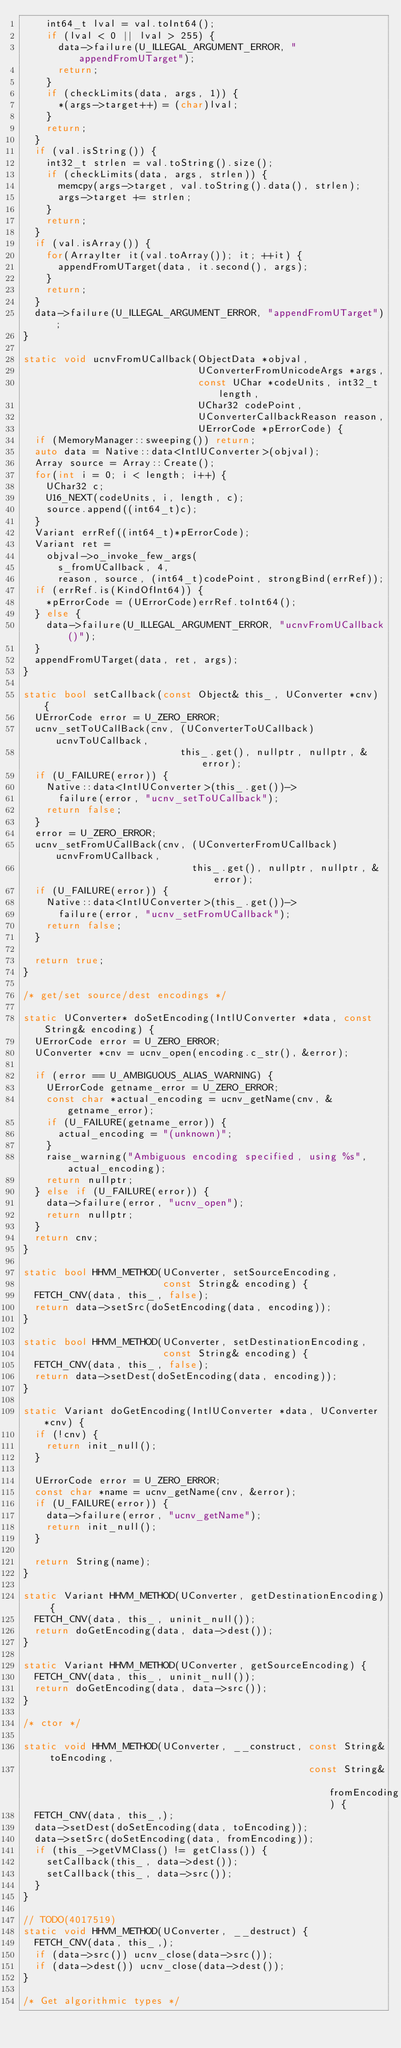<code> <loc_0><loc_0><loc_500><loc_500><_C++_>    int64_t lval = val.toInt64();
    if (lval < 0 || lval > 255) {
      data->failure(U_ILLEGAL_ARGUMENT_ERROR, "appendFromUTarget");
      return;
    }
    if (checkLimits(data, args, 1)) {
      *(args->target++) = (char)lval;
    }
    return;
  }
  if (val.isString()) {
    int32_t strlen = val.toString().size();
    if (checkLimits(data, args, strlen)) {
      memcpy(args->target, val.toString().data(), strlen);
      args->target += strlen;
    }
    return;
  }
  if (val.isArray()) {
    for(ArrayIter it(val.toArray()); it; ++it) {
      appendFromUTarget(data, it.second(), args);
    }
    return;
  }
  data->failure(U_ILLEGAL_ARGUMENT_ERROR, "appendFromUTarget");
}

static void ucnvFromUCallback(ObjectData *objval,
                              UConverterFromUnicodeArgs *args,
                              const UChar *codeUnits, int32_t length,
                              UChar32 codePoint,
                              UConverterCallbackReason reason,
                              UErrorCode *pErrorCode) {
  if (MemoryManager::sweeping()) return;
  auto data = Native::data<IntlUConverter>(objval);
  Array source = Array::Create();
  for(int i = 0; i < length; i++) {
    UChar32 c;
    U16_NEXT(codeUnits, i, length, c);
    source.append((int64_t)c);
  }
  Variant errRef((int64_t)*pErrorCode);
  Variant ret =
    objval->o_invoke_few_args(
      s_fromUCallback, 4,
      reason, source, (int64_t)codePoint, strongBind(errRef));
  if (errRef.is(KindOfInt64)) {
    *pErrorCode = (UErrorCode)errRef.toInt64();
  } else {
    data->failure(U_ILLEGAL_ARGUMENT_ERROR, "ucnvFromUCallback()");
  }
  appendFromUTarget(data, ret, args);
}

static bool setCallback(const Object& this_, UConverter *cnv) {
  UErrorCode error = U_ZERO_ERROR;
  ucnv_setToUCallBack(cnv, (UConverterToUCallback)ucnvToUCallback,
                           this_.get(), nullptr, nullptr, &error);
  if (U_FAILURE(error)) {
    Native::data<IntlUConverter>(this_.get())->
      failure(error, "ucnv_setToUCallback");
    return false;
  }
  error = U_ZERO_ERROR;
  ucnv_setFromUCallBack(cnv, (UConverterFromUCallback)ucnvFromUCallback,
                             this_.get(), nullptr, nullptr, &error);
  if (U_FAILURE(error)) {
    Native::data<IntlUConverter>(this_.get())->
      failure(error, "ucnv_setFromUCallback");
    return false;
  }

  return true;
}

/* get/set source/dest encodings */

static UConverter* doSetEncoding(IntlUConverter *data, const String& encoding) {
  UErrorCode error = U_ZERO_ERROR;
  UConverter *cnv = ucnv_open(encoding.c_str(), &error);

  if (error == U_AMBIGUOUS_ALIAS_WARNING) {
    UErrorCode getname_error = U_ZERO_ERROR;
    const char *actual_encoding = ucnv_getName(cnv, &getname_error);
    if (U_FAILURE(getname_error)) {
      actual_encoding = "(unknown)";
    }
    raise_warning("Ambiguous encoding specified, using %s", actual_encoding);
    return nullptr;
  } else if (U_FAILURE(error)) {
    data->failure(error, "ucnv_open");
    return nullptr;
  }
  return cnv;
}

static bool HHVM_METHOD(UConverter, setSourceEncoding,
                        const String& encoding) {
  FETCH_CNV(data, this_, false);
  return data->setSrc(doSetEncoding(data, encoding));
}

static bool HHVM_METHOD(UConverter, setDestinationEncoding,
                        const String& encoding) {
  FETCH_CNV(data, this_, false);
  return data->setDest(doSetEncoding(data, encoding));
}

static Variant doGetEncoding(IntlUConverter *data, UConverter *cnv) {
  if (!cnv) {
    return init_null();
  }

  UErrorCode error = U_ZERO_ERROR;
  const char *name = ucnv_getName(cnv, &error);
  if (U_FAILURE(error)) {
    data->failure(error, "ucnv_getName");
    return init_null();
  }

  return String(name);
}

static Variant HHVM_METHOD(UConverter, getDestinationEncoding) {
  FETCH_CNV(data, this_, uninit_null());
  return doGetEncoding(data, data->dest());
}

static Variant HHVM_METHOD(UConverter, getSourceEncoding) {
  FETCH_CNV(data, this_, uninit_null());
  return doGetEncoding(data, data->src());
}

/* ctor */

static void HHVM_METHOD(UConverter, __construct, const String& toEncoding,
                                                 const String& fromEncoding) {
  FETCH_CNV(data, this_,);
  data->setDest(doSetEncoding(data, toEncoding));
  data->setSrc(doSetEncoding(data, fromEncoding));
  if (this_->getVMClass() != getClass()) {
    setCallback(this_, data->dest());
    setCallback(this_, data->src());
  }
}

// TODO(4017519)
static void HHVM_METHOD(UConverter, __destruct) {
  FETCH_CNV(data, this_,);
  if (data->src()) ucnv_close(data->src());
  if (data->dest()) ucnv_close(data->dest());
}

/* Get algorithmic types */
</code> 